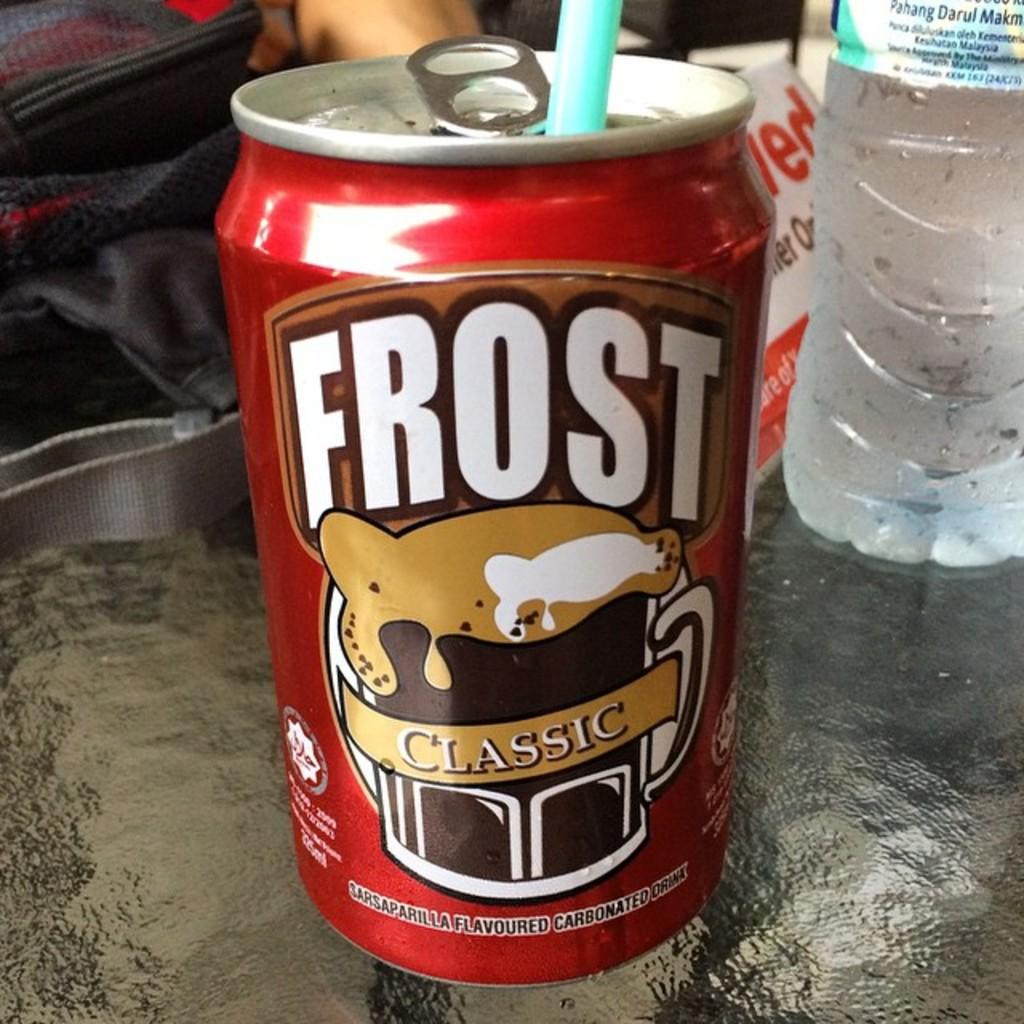Is this soda original or classic?
Offer a terse response. Classic. 